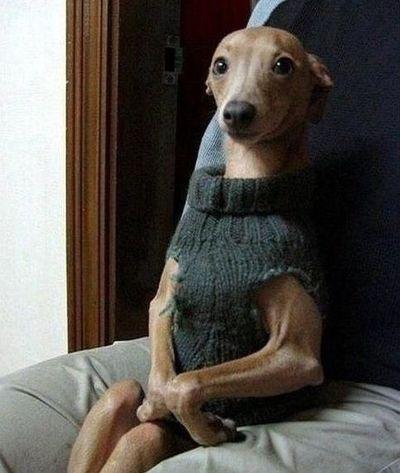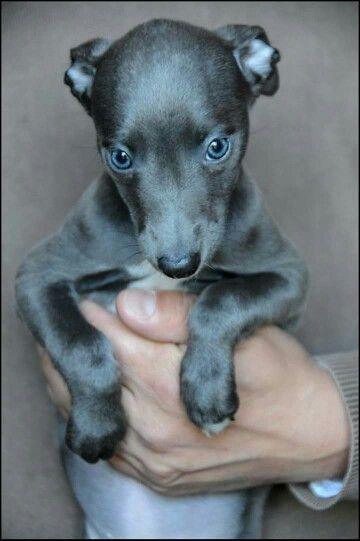The first image is the image on the left, the second image is the image on the right. Analyze the images presented: Is the assertion "there is an animal wrapped up in something blue in the image on the right side." valid? Answer yes or no. No. 